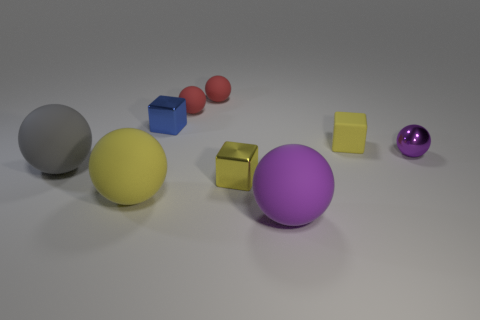Are there fewer yellow metal objects than green rubber spheres?
Your answer should be compact. No. There is a yellow metal thing; is its size the same as the metal block behind the yellow matte cube?
Ensure brevity in your answer.  Yes. There is a metal thing that is in front of the large object that is behind the tiny yellow metal object; what color is it?
Your answer should be compact. Yellow. How many objects are rubber objects that are behind the purple metal object or yellow rubber cubes left of the purple metallic object?
Your answer should be very brief. 3. Do the rubber cube and the yellow metallic cube have the same size?
Give a very brief answer. Yes. Are there any other things that have the same size as the gray object?
Provide a succinct answer. Yes. Do the tiny yellow thing behind the gray rubber sphere and the tiny metallic object on the right side of the tiny rubber block have the same shape?
Give a very brief answer. No. The blue shiny object is what size?
Ensure brevity in your answer.  Small. What material is the yellow object to the left of the small shiny block behind the small yellow block that is in front of the yellow rubber block made of?
Your response must be concise. Rubber. How many other objects are there of the same color as the small metal sphere?
Provide a short and direct response. 1. 